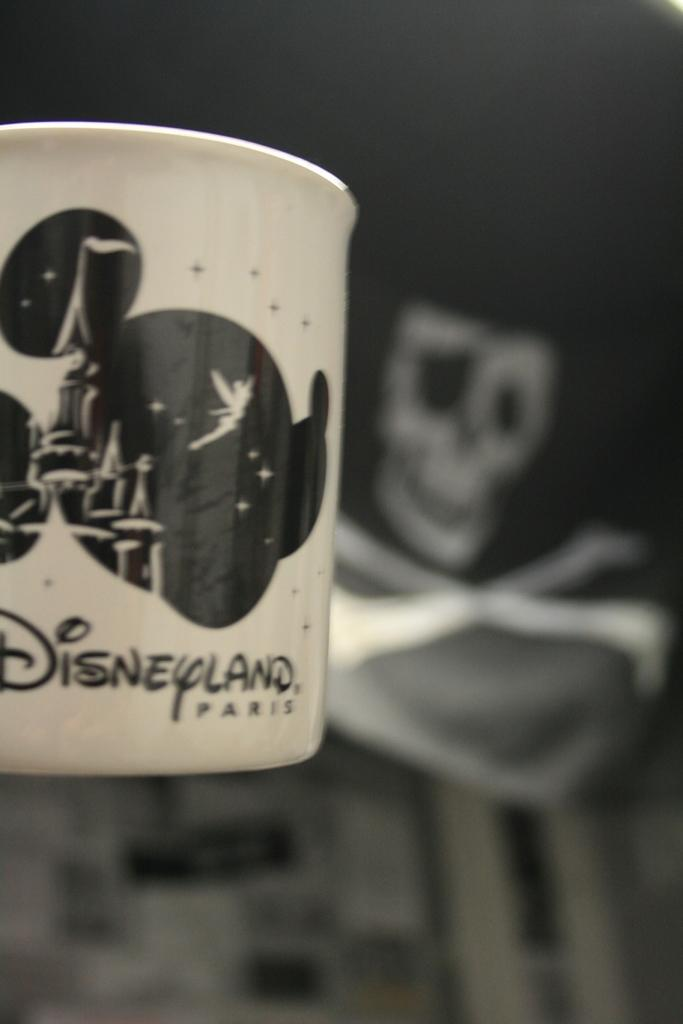<image>
Provide a brief description of the given image. A Disneyland Paris mug being held up with a skull and crossbones in the background. 